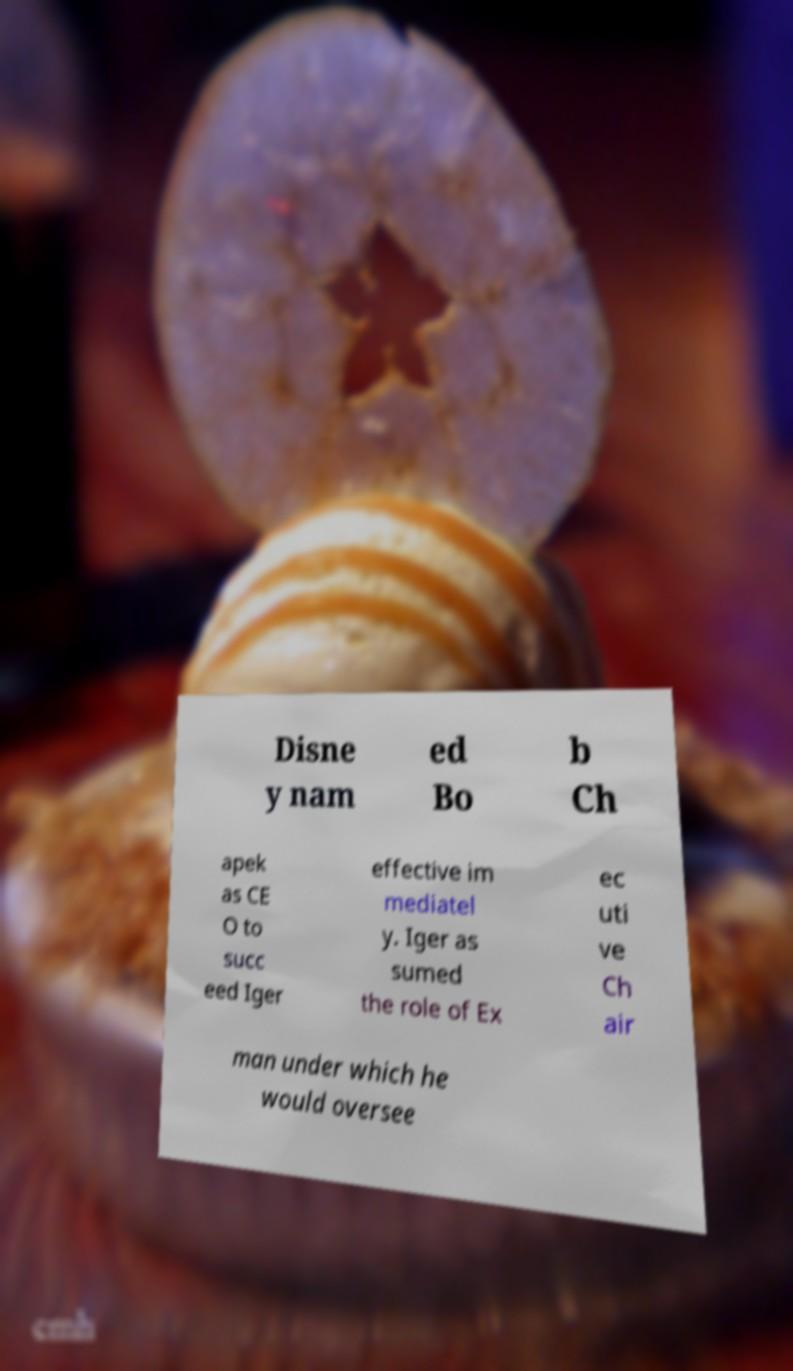Please identify and transcribe the text found in this image. Disne y nam ed Bo b Ch apek as CE O to succ eed Iger effective im mediatel y. Iger as sumed the role of Ex ec uti ve Ch air man under which he would oversee 